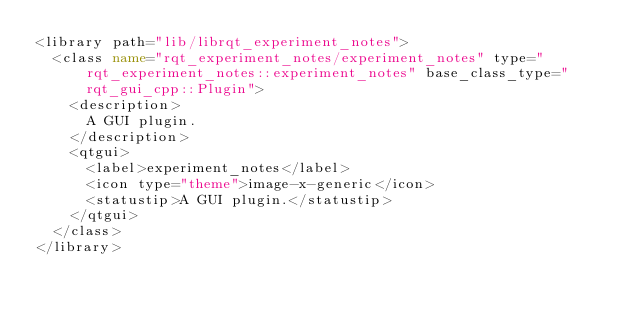Convert code to text. <code><loc_0><loc_0><loc_500><loc_500><_XML_><library path="lib/librqt_experiment_notes">
  <class name="rqt_experiment_notes/experiment_notes" type="rqt_experiment_notes::experiment_notes" base_class_type="rqt_gui_cpp::Plugin">
    <description>
      A GUI plugin.
    </description>
    <qtgui>
      <label>experiment_notes</label>
      <icon type="theme">image-x-generic</icon>
      <statustip>A GUI plugin.</statustip>
    </qtgui>
  </class>
</library>
</code> 